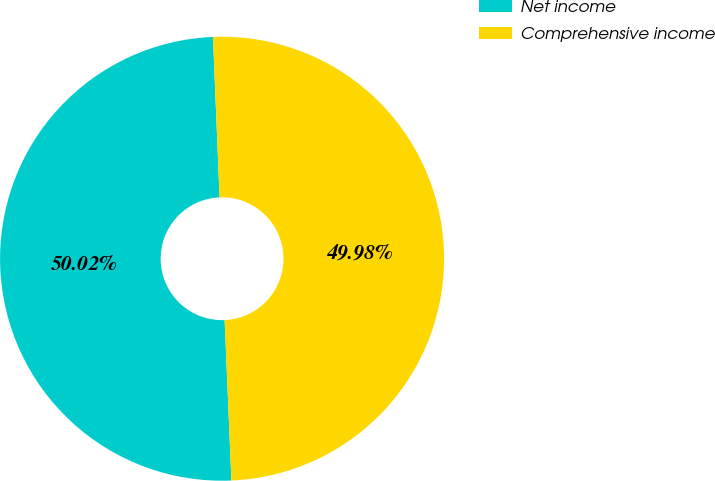<chart> <loc_0><loc_0><loc_500><loc_500><pie_chart><fcel>Net income<fcel>Comprehensive income<nl><fcel>50.02%<fcel>49.98%<nl></chart> 